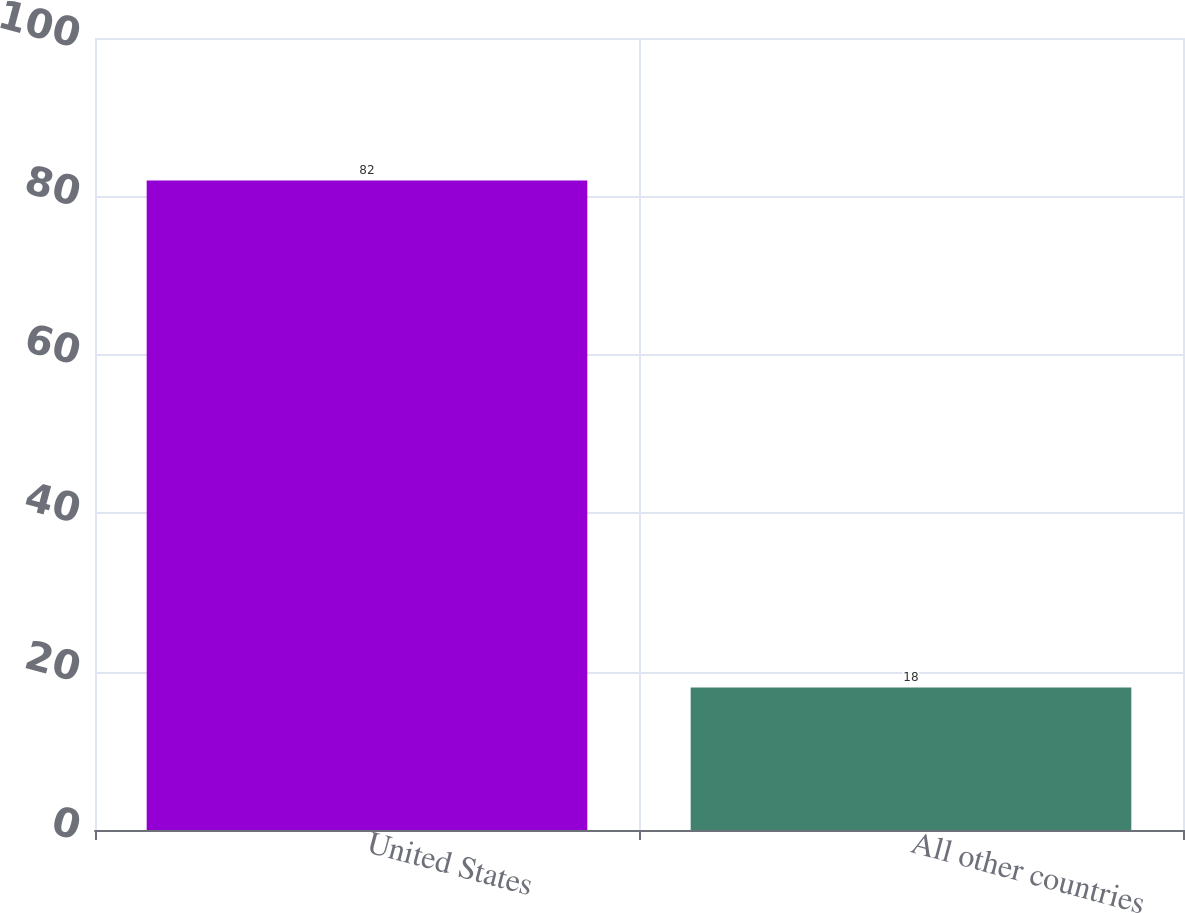<chart> <loc_0><loc_0><loc_500><loc_500><bar_chart><fcel>United States<fcel>All other countries<nl><fcel>82<fcel>18<nl></chart> 